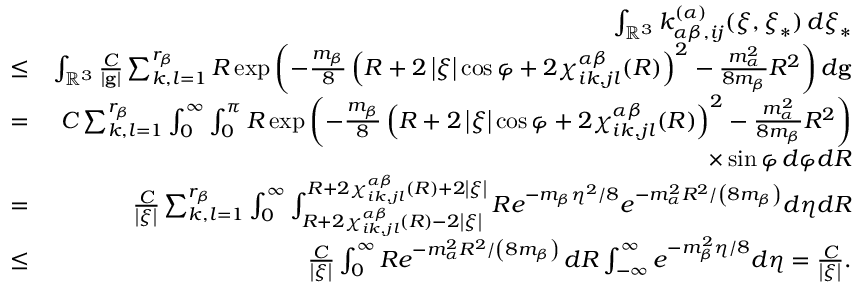<formula> <loc_0><loc_0><loc_500><loc_500>\begin{array} { r l r } & { \int _ { \mathbb { R } ^ { 3 } } k _ { \alpha \beta , i j } ^ { \left ( \alpha \right ) } ( \xi , \xi _ { \ast } ) \, d \xi _ { \ast } } \\ & { \leq } & { \int _ { \mathbb { R } ^ { 3 } } \frac { C } { \left | g \right | } \sum _ { k , l = 1 } ^ { r _ { \beta } } R \exp \left ( - \frac { m _ { \beta } } { 8 } \left ( R + 2 \left | \xi \right | \cos \varphi + 2 \chi _ { i k , j l } ^ { \alpha \beta } ( R ) \right ) ^ { 2 } - \frac { m _ { \alpha } ^ { 2 } } { 8 m _ { \beta } } R ^ { 2 } \right ) d g } \\ & { = } & { C \sum _ { k , l = 1 } ^ { r _ { \beta } } \int _ { 0 } ^ { \infty } \int _ { 0 } ^ { \pi } R \exp \left ( - \frac { m _ { \beta } } { 8 } \left ( R + 2 \left | \xi \right | \cos \varphi + 2 \chi _ { i k , j l } ^ { \alpha \beta } ( R ) \right ) ^ { 2 } - \frac { m _ { \alpha } ^ { 2 } } { 8 m _ { \beta } } R ^ { 2 } \right ) } \\ & { \times \sin \varphi \, d \varphi d R } \\ & { = } & { \frac { C } { \left | \xi \right | } \sum _ { k , l = 1 } ^ { r _ { \beta } } \int _ { 0 } ^ { \infty } \int _ { R + 2 \chi _ { i k , j l } ^ { \alpha \beta } ( R ) - 2 \left | \xi \right | } ^ { R + 2 \chi _ { i k , j l } ^ { \alpha \beta } ( R ) + 2 \left | \xi \right | } R e ^ { - m _ { \beta } \eta ^ { 2 } / 8 } e ^ { - m _ { \alpha } ^ { 2 } R ^ { 2 } / \left ( 8 m _ { \beta } \right ) } d \eta d R } \\ & { \leq } & { \frac { C } { \left | \xi \right | } \int _ { 0 } ^ { \infty } R e ^ { - m _ { \alpha } ^ { 2 } R ^ { 2 } / \left ( 8 m _ { \beta } \right ) } \, d R \int _ { - \infty } ^ { \infty } e ^ { - m _ { \beta } ^ { 2 } \eta / 8 } d \eta = \frac { C } { \left | \xi \right | } . } \end{array}</formula> 